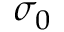<formula> <loc_0><loc_0><loc_500><loc_500>\sigma _ { 0 }</formula> 